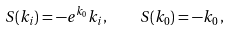Convert formula to latex. <formula><loc_0><loc_0><loc_500><loc_500>S ( k _ { i } ) = - e ^ { k _ { 0 } } k _ { i } , \quad S ( k _ { 0 } ) = - k _ { 0 } \, ,</formula> 